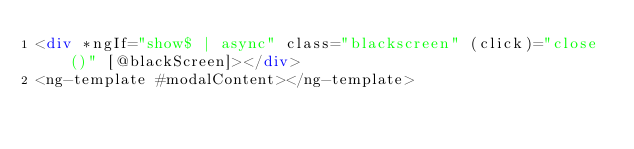Convert code to text. <code><loc_0><loc_0><loc_500><loc_500><_HTML_><div *ngIf="show$ | async" class="blackscreen" (click)="close()" [@blackScreen]></div>
<ng-template #modalContent></ng-template>
</code> 